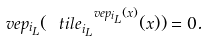<formula> <loc_0><loc_0><loc_500><loc_500>\ v e p _ { i _ { L } } ( \ t i l e _ { i _ { L } } ^ { \ v e p _ { i _ { L } } ( x ) } ( x ) ) = 0 .</formula> 